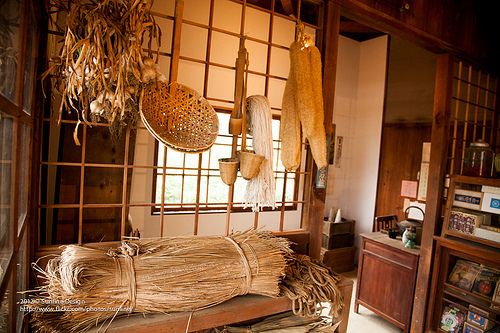<image>
Can you confirm if the chair is behind the table? Yes. From this viewpoint, the chair is positioned behind the table, with the table partially or fully occluding the chair. 